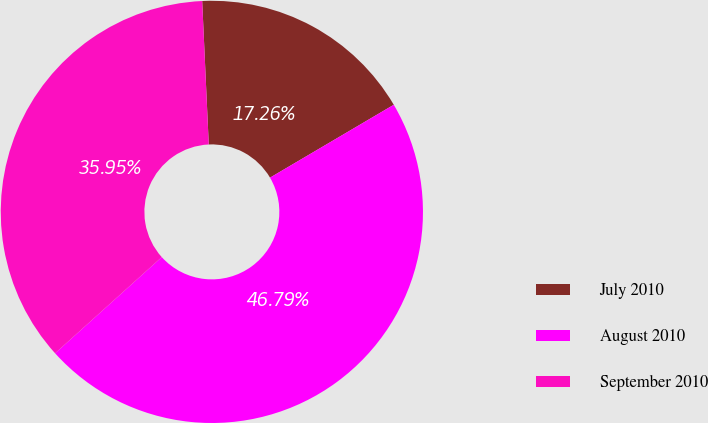Convert chart. <chart><loc_0><loc_0><loc_500><loc_500><pie_chart><fcel>July 2010<fcel>August 2010<fcel>September 2010<nl><fcel>17.26%<fcel>46.79%<fcel>35.95%<nl></chart> 